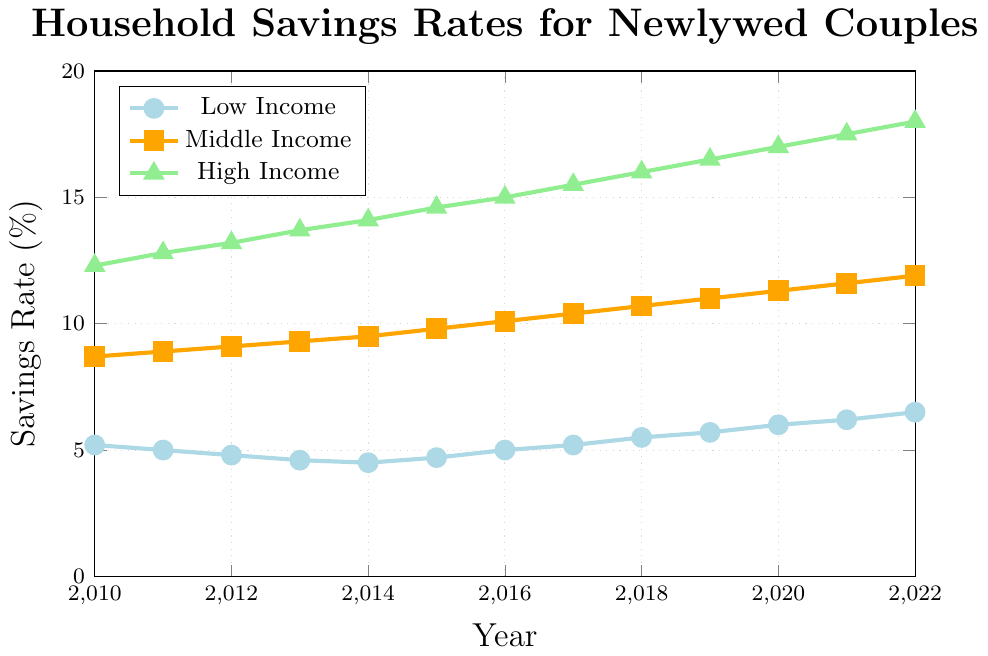what is the midline value between savings rates for High Income and Low Income couples in 2022? To find the midline value, take the savings rates of High Income and Low Income couples in 2022, add them up and divide by 2. (18.0 + 6.5) / 2 = 12.25
Answer: 12.25 Which income bracket experienced the highest increase in household savings rates from 2010 to 2022? To find the largest increase, subtract the initial savings rate from the final savings rate for each income bracket: Low Income: 6.5 - 5.2 = 1.3, Middle Income: 11.9 - 8.7 = 3.2, High Income: 18.0 - 12.3 = 5.7. High Income experienced the highest increase.
Answer: High Income Compare the savings rate trend for Middle Income and High Income couples from 2010 to 2014. Which had a steeper increase? Calculate the difference in savings rates for both income brackets between 2010 and 2014. Middle Income: 9.5 - 8.7 = 0.8, High Income: 14.1 - 12.3 = 1.8. Hence, the High Income couples had a steeper increase.
Answer: High Income What is the average savings rate for Middle Income couples between 2010 and 2022? Sum the Middle Income savings rates from 2010 to 2022 and divide by the number of years. (8.7 + 8.9 + 9.1 + 9.3 + 9.5 + 9.8 + 10.1 + 10.4 + 10.7 + 11.0 + 11.3 + 11.6 + 11.9) / 13 ≈ 10.1
Answer: 10.1 In which year did the Low Income couples experience their minimum savings rate, and what was the rate? Review the data and find the minimum savings rate for Low Income couples, which occurred in 2014 with a rate of 4.5
Answer: 2014, 4.5 